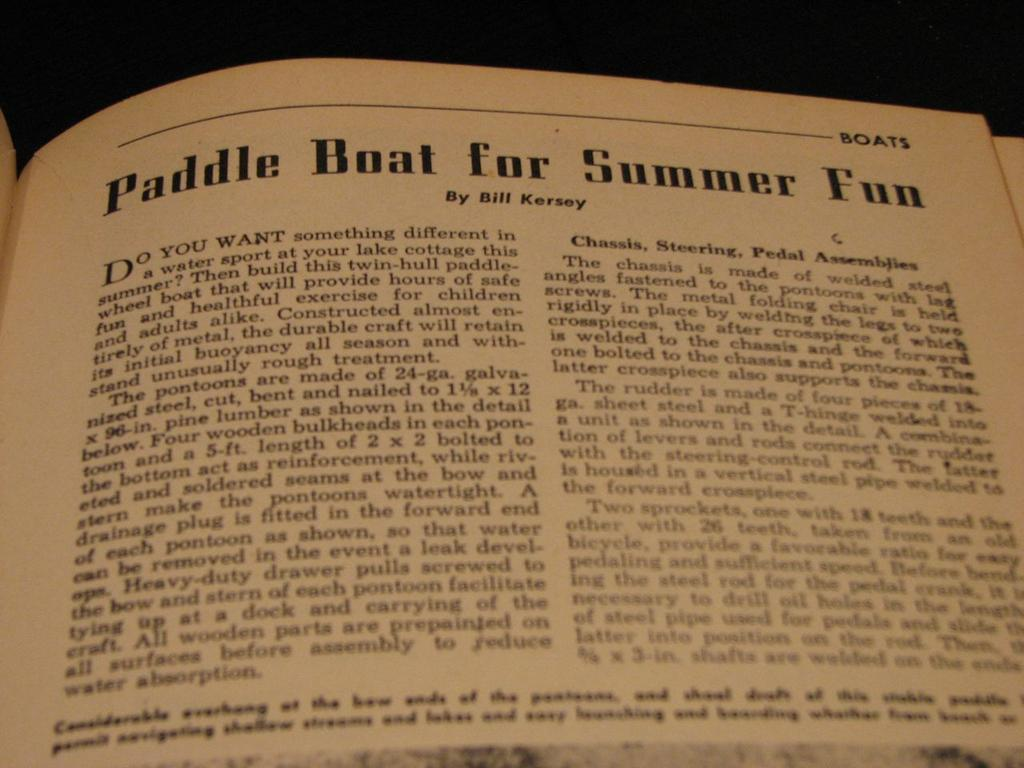<image>
Render a clear and concise summary of the photo. A book with the title Paddle Boat for Summer Fun 